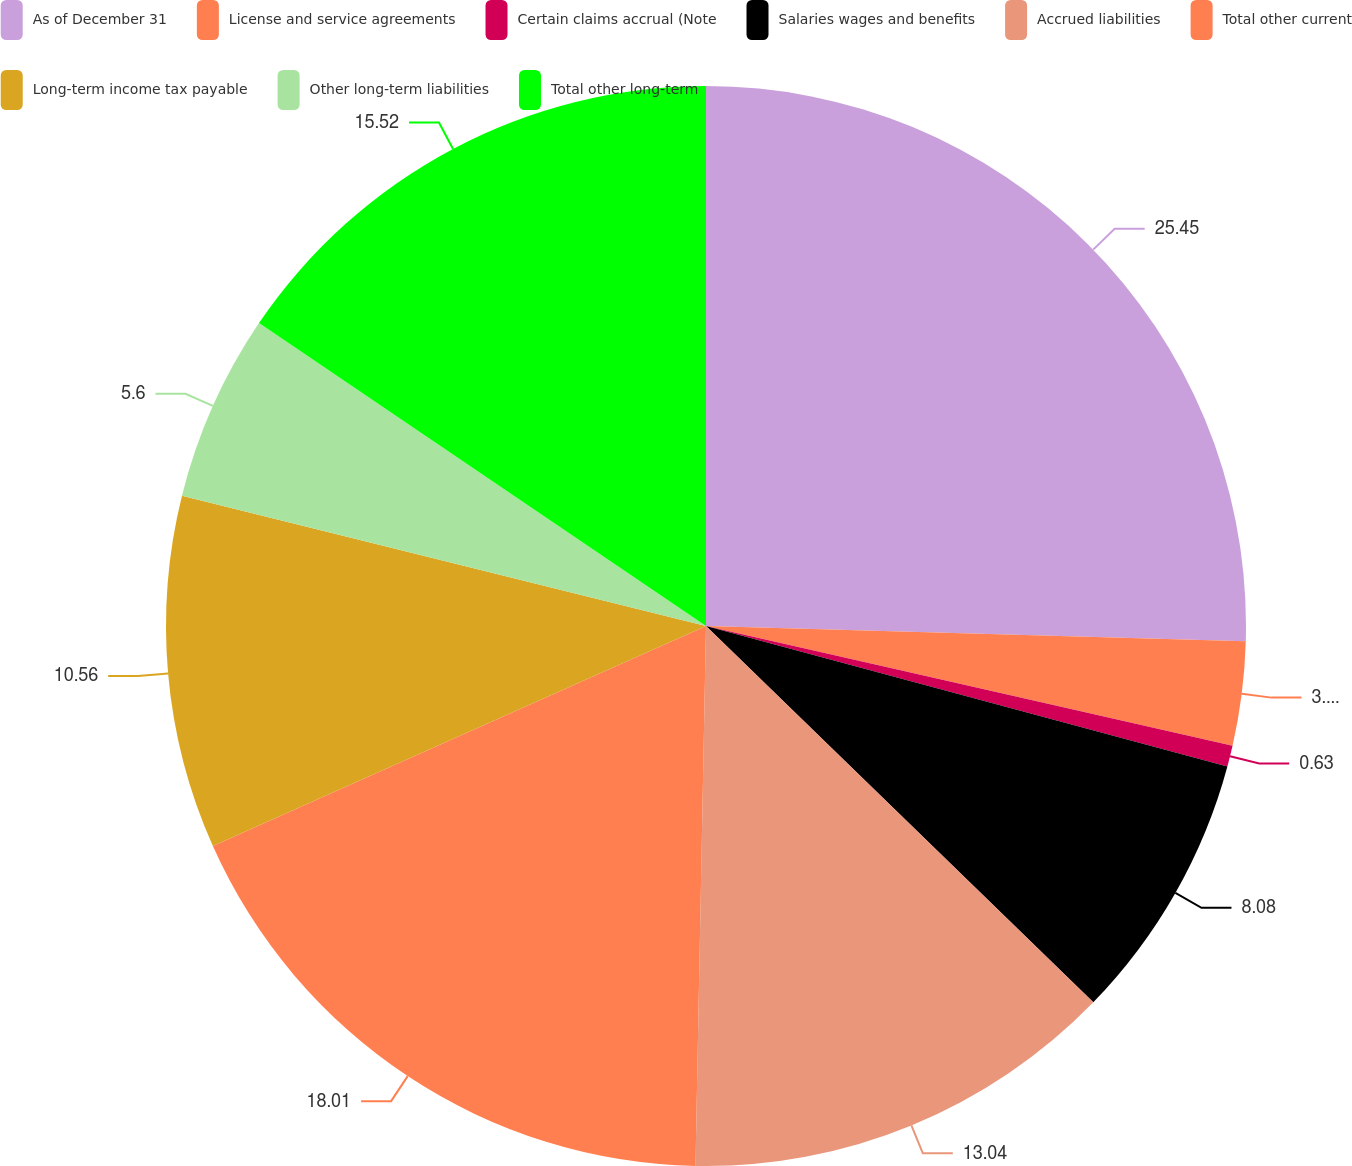<chart> <loc_0><loc_0><loc_500><loc_500><pie_chart><fcel>As of December 31<fcel>License and service agreements<fcel>Certain claims accrual (Note<fcel>Salaries wages and benefits<fcel>Accrued liabilities<fcel>Total other current<fcel>Long-term income tax payable<fcel>Other long-term liabilities<fcel>Total other long-term<nl><fcel>25.45%<fcel>3.11%<fcel>0.63%<fcel>8.08%<fcel>13.04%<fcel>18.01%<fcel>10.56%<fcel>5.6%<fcel>15.52%<nl></chart> 